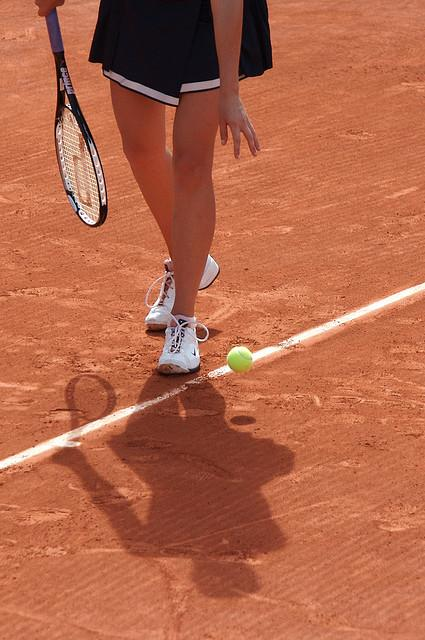What color are the logos on the shoes which this tennis playing woman is wearing?

Choices:
A) pink
B) red
C) blue
D) black black 